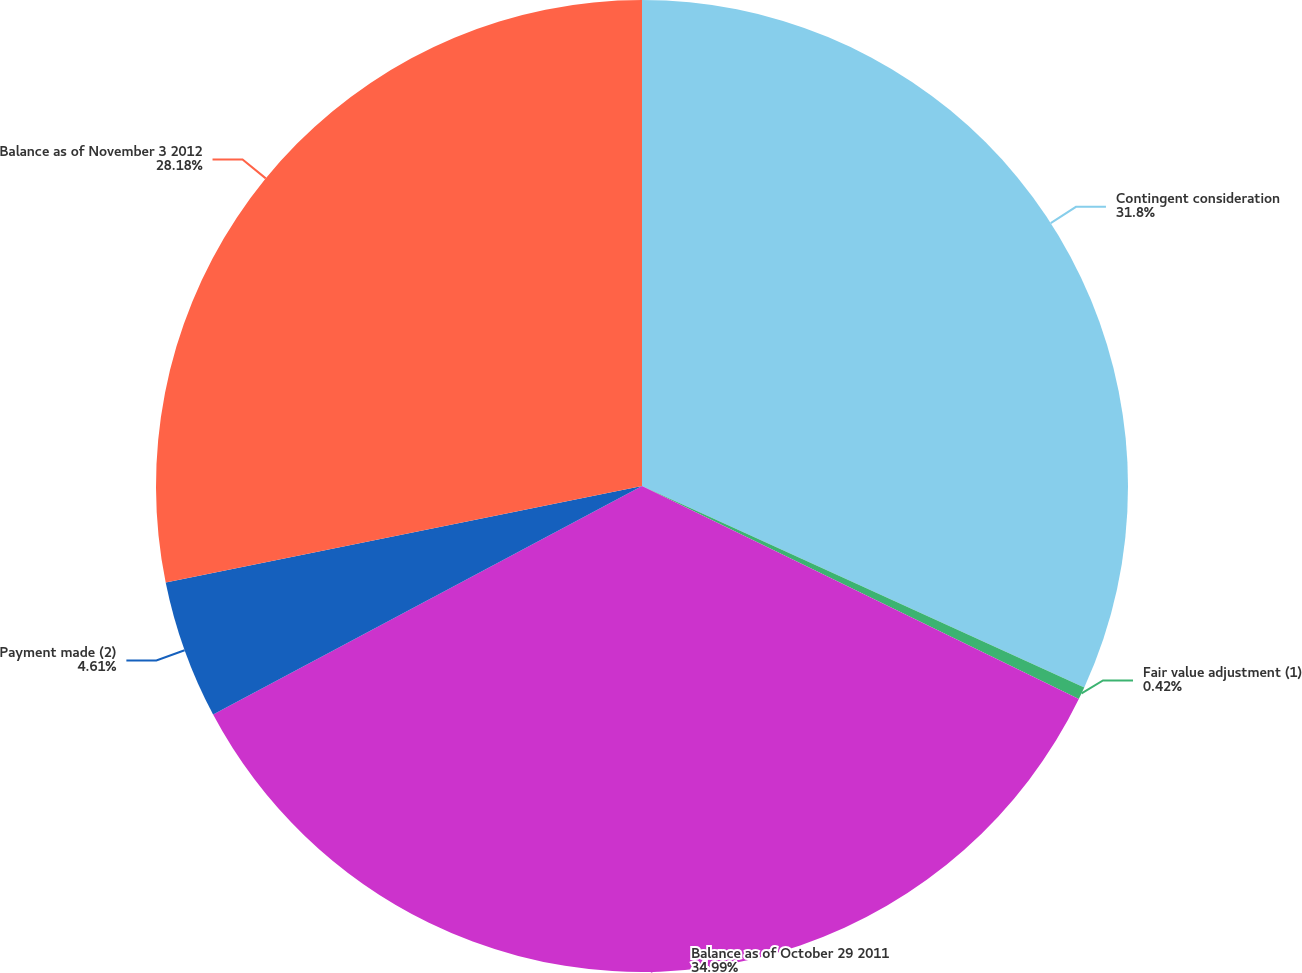<chart> <loc_0><loc_0><loc_500><loc_500><pie_chart><fcel>Contingent consideration<fcel>Fair value adjustment (1)<fcel>Balance as of October 29 2011<fcel>Payment made (2)<fcel>Balance as of November 3 2012<nl><fcel>31.8%<fcel>0.42%<fcel>34.98%<fcel>4.61%<fcel>28.18%<nl></chart> 